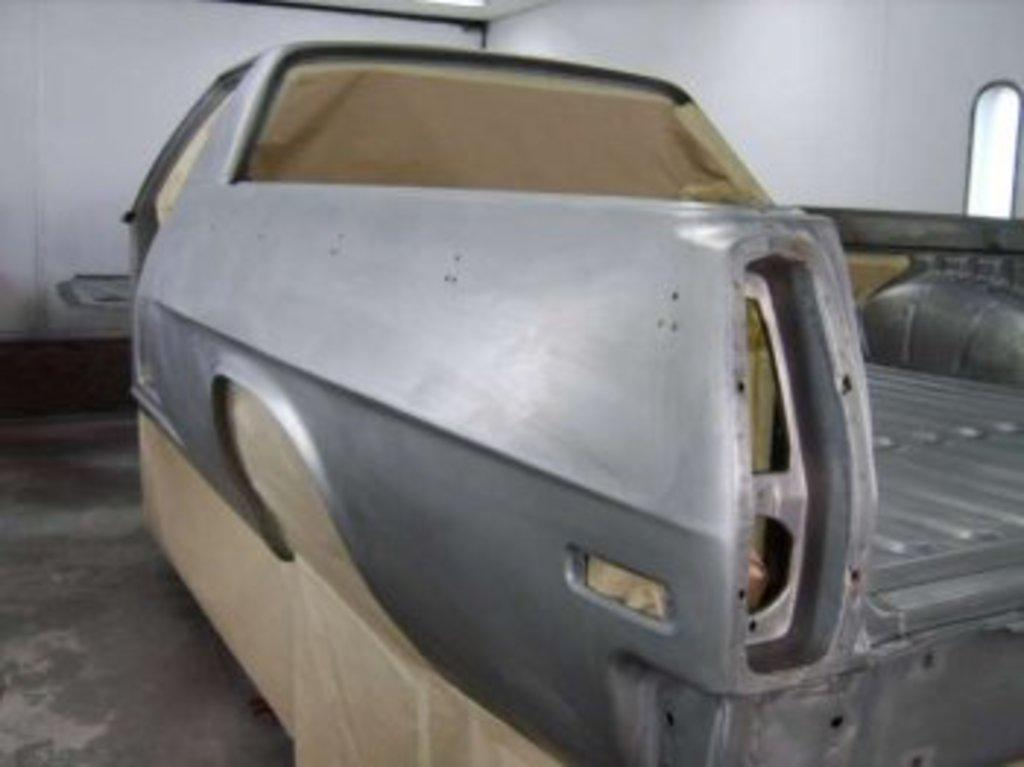What is on the floor in the image? There is a vehicle on the floor in the image. What can be seen in the background of the image? There is a wall and a window in the background of the image. What type of pail is being used to perform addition on the street in the image? There is no pail or addition being performed on the street in the image. 